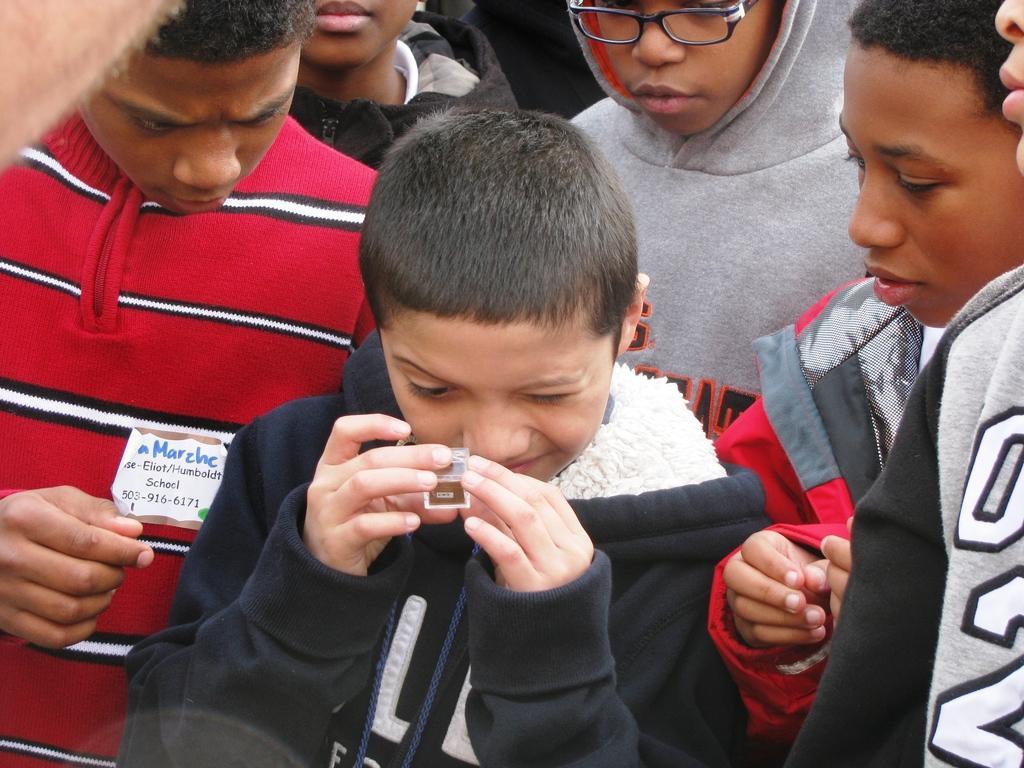In one or two sentences, can you explain what this image depicts? This image consists of many people. The boy standing in the front is wearing a black jacket. On the left, the boy is wearing a red jacket. 